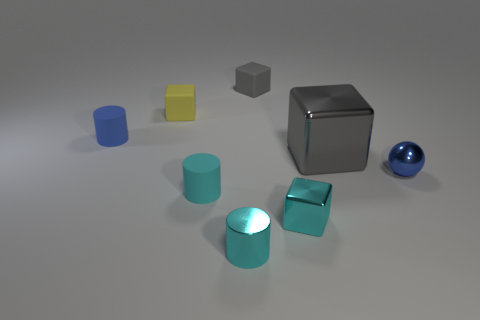How many objects are cyan blocks that are right of the yellow rubber object or big metallic objects?
Provide a short and direct response. 2. Is there another gray matte thing that has the same size as the gray matte object?
Provide a succinct answer. No. What material is the cyan cube that is the same size as the yellow object?
Give a very brief answer. Metal. What shape is the tiny thing that is both to the right of the gray matte cube and to the left of the large shiny cube?
Your answer should be very brief. Cube. There is a rubber cylinder in front of the small blue metal ball; what color is it?
Give a very brief answer. Cyan. What is the size of the block that is behind the tiny sphere and in front of the yellow matte block?
Provide a succinct answer. Large. Do the tiny blue cylinder and the gray thing that is behind the big block have the same material?
Keep it short and to the point. Yes. How many cyan metallic objects are the same shape as the tiny gray thing?
Make the answer very short. 1. What material is the small block that is the same color as the metallic cylinder?
Make the answer very short. Metal. What number of large brown metallic cylinders are there?
Provide a succinct answer. 0. 